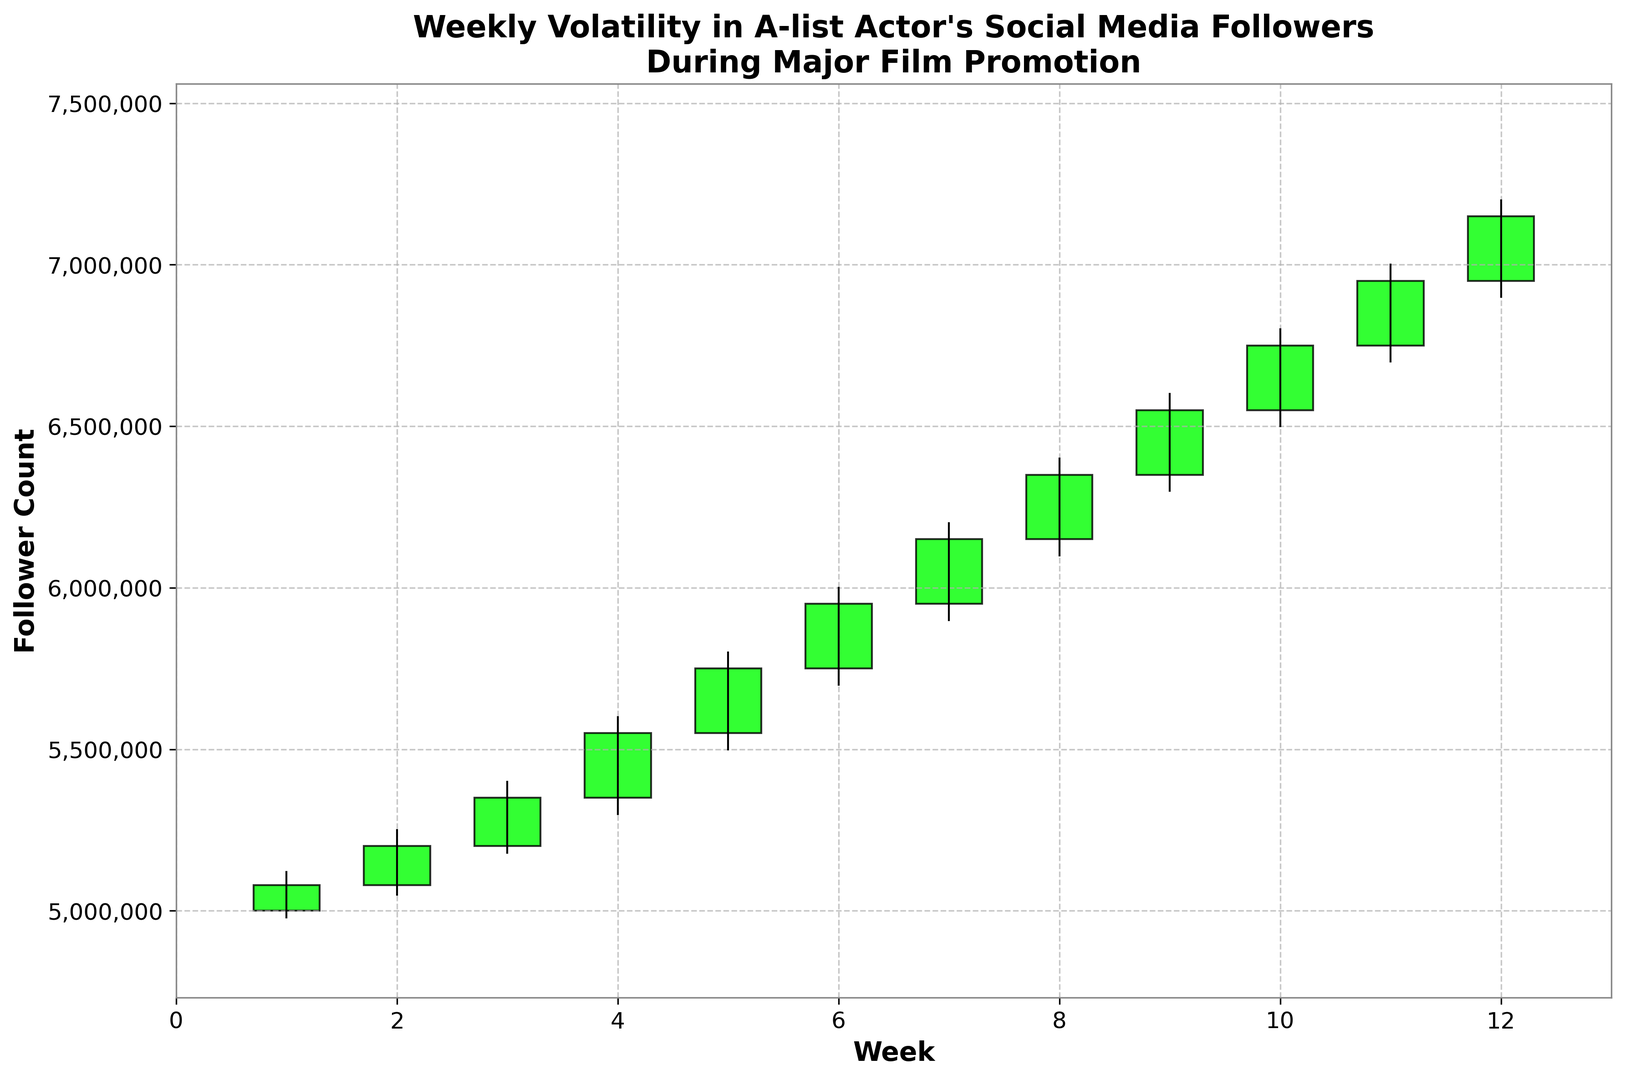What was the highest follower count recorded during the 12-week period? To find the highest follower count, we observe the highest points on the chart, which are represented by the top of the highest green or pink bars. The highest point is at week 12 with a high of 7,200,000 followers.
Answer: 7,200,000 Which week showed the largest increase in follower count from the opening to closing value? To determine the week with the largest increase, we look at the height difference between the bottom and top of the green bars. The longest green bar represents the largest increase. That occurs in week 7, where the follower count increased from 5,950,000 to 6,150,000, a difference of 200,000.
Answer: Week 7 During which week did the follower count experience the greatest volatility? Volatility can be assessed by the length of the lines extending from the top and bottom of the weekly bars. The week with the longest line represents the greatest volatility. Week 12 displays the most extended line from 6,900,000 to 7,200,000.
Answer: Week 12 Was there any week where the follower count at the close was lower than at the open? Red bars indicate weeks where the closing follower count was lower than the opening follower count. There are no red bars in the chart, indicating no such weeks within the 12-week period.
Answer: No How many weeks showed a positive gain in the follower count from the opening to closing values? Positive gain weeks are represented by green bars. Counting the green bars, we observe that all 12 bars are green.
Answer: 12 weeks In which week did the follower count experience the smallest range (difference between high and low)? The smallest range can be identified by finding the week with the shortest high to low vertical line. The week with the smallest range is week 1, where the range is from 4,980,000 to 5,120,000, a difference of 140,000.
Answer: Week 1 What is the average closing follower count over the 12 weeks? To find the average closing follower count, sum the closing values for all weeks (50,800,000) and divide by the number of weeks (12). Average = 50,800,000 / 12 = 4,233,333.33.
Answer: 5,233,333.33 Compare the follower counts at the close of weeks 6 and 12. Which week had more followers? We compare the closing values of week 6 (5,950,000) and week 12 (7,150,000). Week 12 had more followers.
Answer: Week 12 